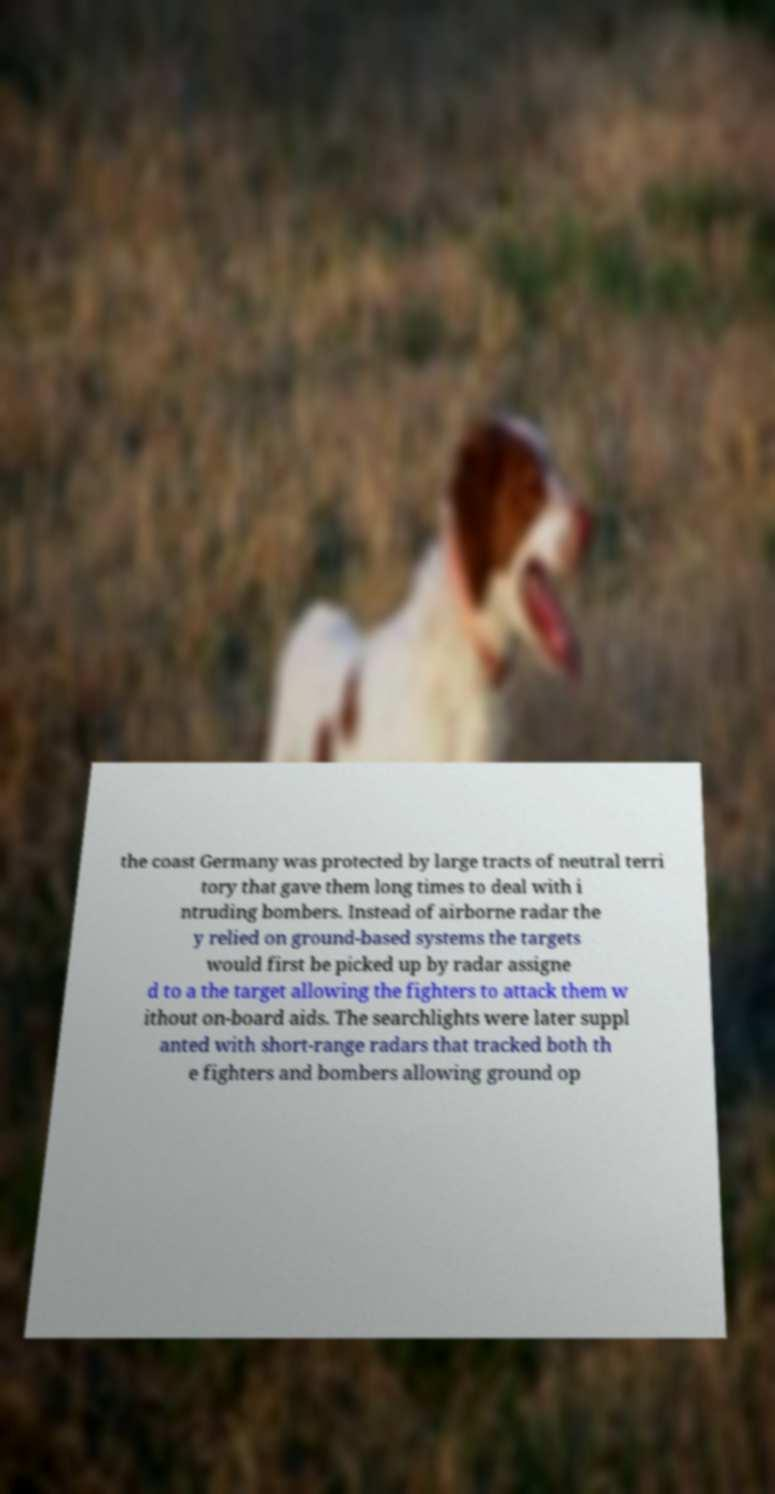For documentation purposes, I need the text within this image transcribed. Could you provide that? the coast Germany was protected by large tracts of neutral terri tory that gave them long times to deal with i ntruding bombers. Instead of airborne radar the y relied on ground-based systems the targets would first be picked up by radar assigne d to a the target allowing the fighters to attack them w ithout on-board aids. The searchlights were later suppl anted with short-range radars that tracked both th e fighters and bombers allowing ground op 